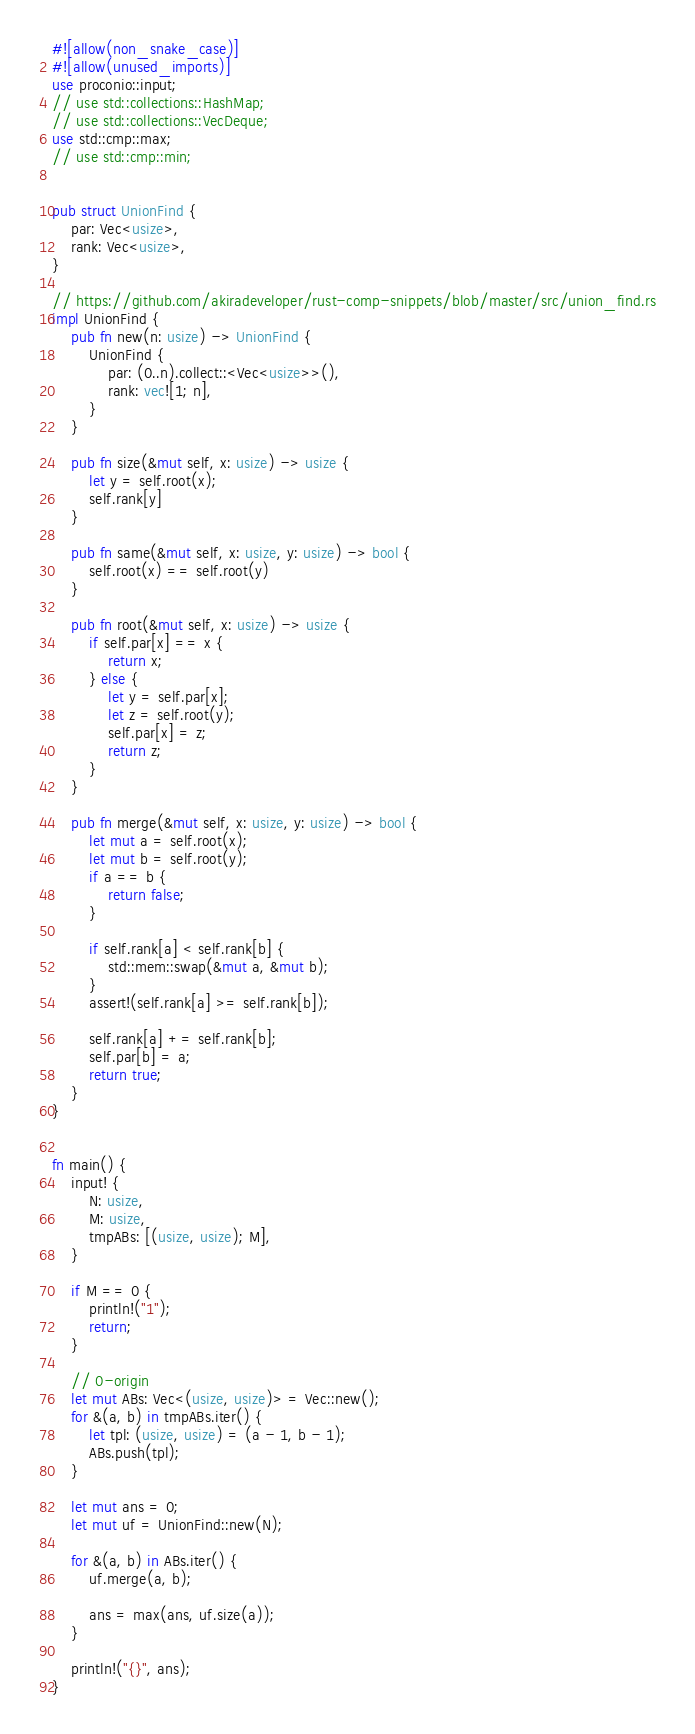Convert code to text. <code><loc_0><loc_0><loc_500><loc_500><_Rust_>#![allow(non_snake_case)]
#![allow(unused_imports)]
use proconio::input;
// use std::collections::HashMap;
// use std::collections::VecDeque;
use std::cmp::max;
// use std::cmp::min;


pub struct UnionFind {
    par: Vec<usize>,
    rank: Vec<usize>,
}

// https://github.com/akiradeveloper/rust-comp-snippets/blob/master/src/union_find.rs
impl UnionFind {
    pub fn new(n: usize) -> UnionFind {
        UnionFind {
            par: (0..n).collect::<Vec<usize>>(),
            rank: vec![1; n],
        }
    }

    pub fn size(&mut self, x: usize) -> usize {
        let y = self.root(x);
        self.rank[y]
    }

    pub fn same(&mut self, x: usize, y: usize) -> bool {
        self.root(x) == self.root(y)
    }

    pub fn root(&mut self, x: usize) -> usize {
        if self.par[x] == x {
            return x;
        } else {
            let y = self.par[x];
            let z = self.root(y);
            self.par[x] = z;
            return z;
        }
    }

    pub fn merge(&mut self, x: usize, y: usize) -> bool {
        let mut a = self.root(x);
        let mut b = self.root(y);
        if a == b {
            return false;
        }

        if self.rank[a] < self.rank[b] {
            std::mem::swap(&mut a, &mut b);
        }
        assert!(self.rank[a] >= self.rank[b]);

        self.rank[a] += self.rank[b];
        self.par[b] = a;
        return true;
    }
}


fn main() {
    input! {
        N: usize,
        M: usize,
        tmpABs: [(usize, usize); M],
    }

    if M == 0 {
        println!("1");
        return;
    }

    // 0-origin
    let mut ABs: Vec<(usize, usize)> = Vec::new();
    for &(a, b) in tmpABs.iter() {
        let tpl: (usize, usize) = (a - 1, b - 1);
        ABs.push(tpl);
    }

    let mut ans = 0;
    let mut uf = UnionFind::new(N);

    for &(a, b) in ABs.iter() {
        uf.merge(a, b);

        ans = max(ans, uf.size(a));
    }

    println!("{}", ans);
}
</code> 